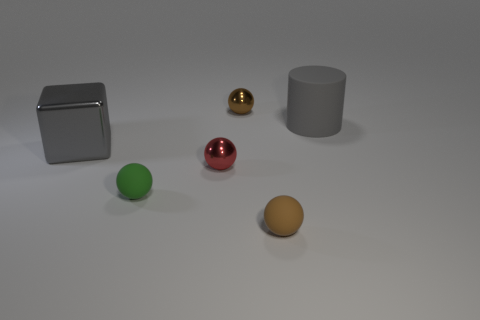Subtract all gray cubes. How many brown spheres are left? 2 Subtract all red shiny spheres. How many spheres are left? 3 Subtract all green spheres. How many spheres are left? 3 Subtract 2 spheres. How many spheres are left? 2 Add 3 small metallic spheres. How many objects exist? 9 Subtract all red spheres. Subtract all green cubes. How many spheres are left? 3 Subtract all spheres. How many objects are left? 2 Add 3 tiny green balls. How many tiny green balls are left? 4 Add 1 cyan rubber cylinders. How many cyan rubber cylinders exist? 1 Subtract 0 yellow cubes. How many objects are left? 6 